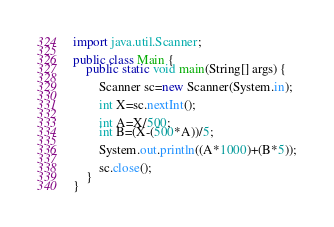Convert code to text. <code><loc_0><loc_0><loc_500><loc_500><_Java_>import java.util.Scanner;
 
public class Main {
	public static void main(String[] args) {
		
		Scanner sc=new Scanner(System.in);
		
		int X=sc.nextInt();
		
		int A=X/500;
		int B=(X-(500*A))/5;
		
		System.out.println((A*1000)+(B*5));
		
		sc.close();
	}
}</code> 